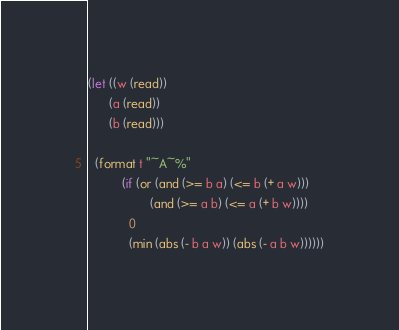<code> <loc_0><loc_0><loc_500><loc_500><_Lisp_>(let ((w (read))
      (a (read))
      (b (read)))

  (format t "~A~%"
          (if (or (and (>= b a) (<= b (+ a w)))
                  (and (>= a b) (<= a (+ b w))))
            0
            (min (abs (- b a w)) (abs (- a b w))))))
</code> 